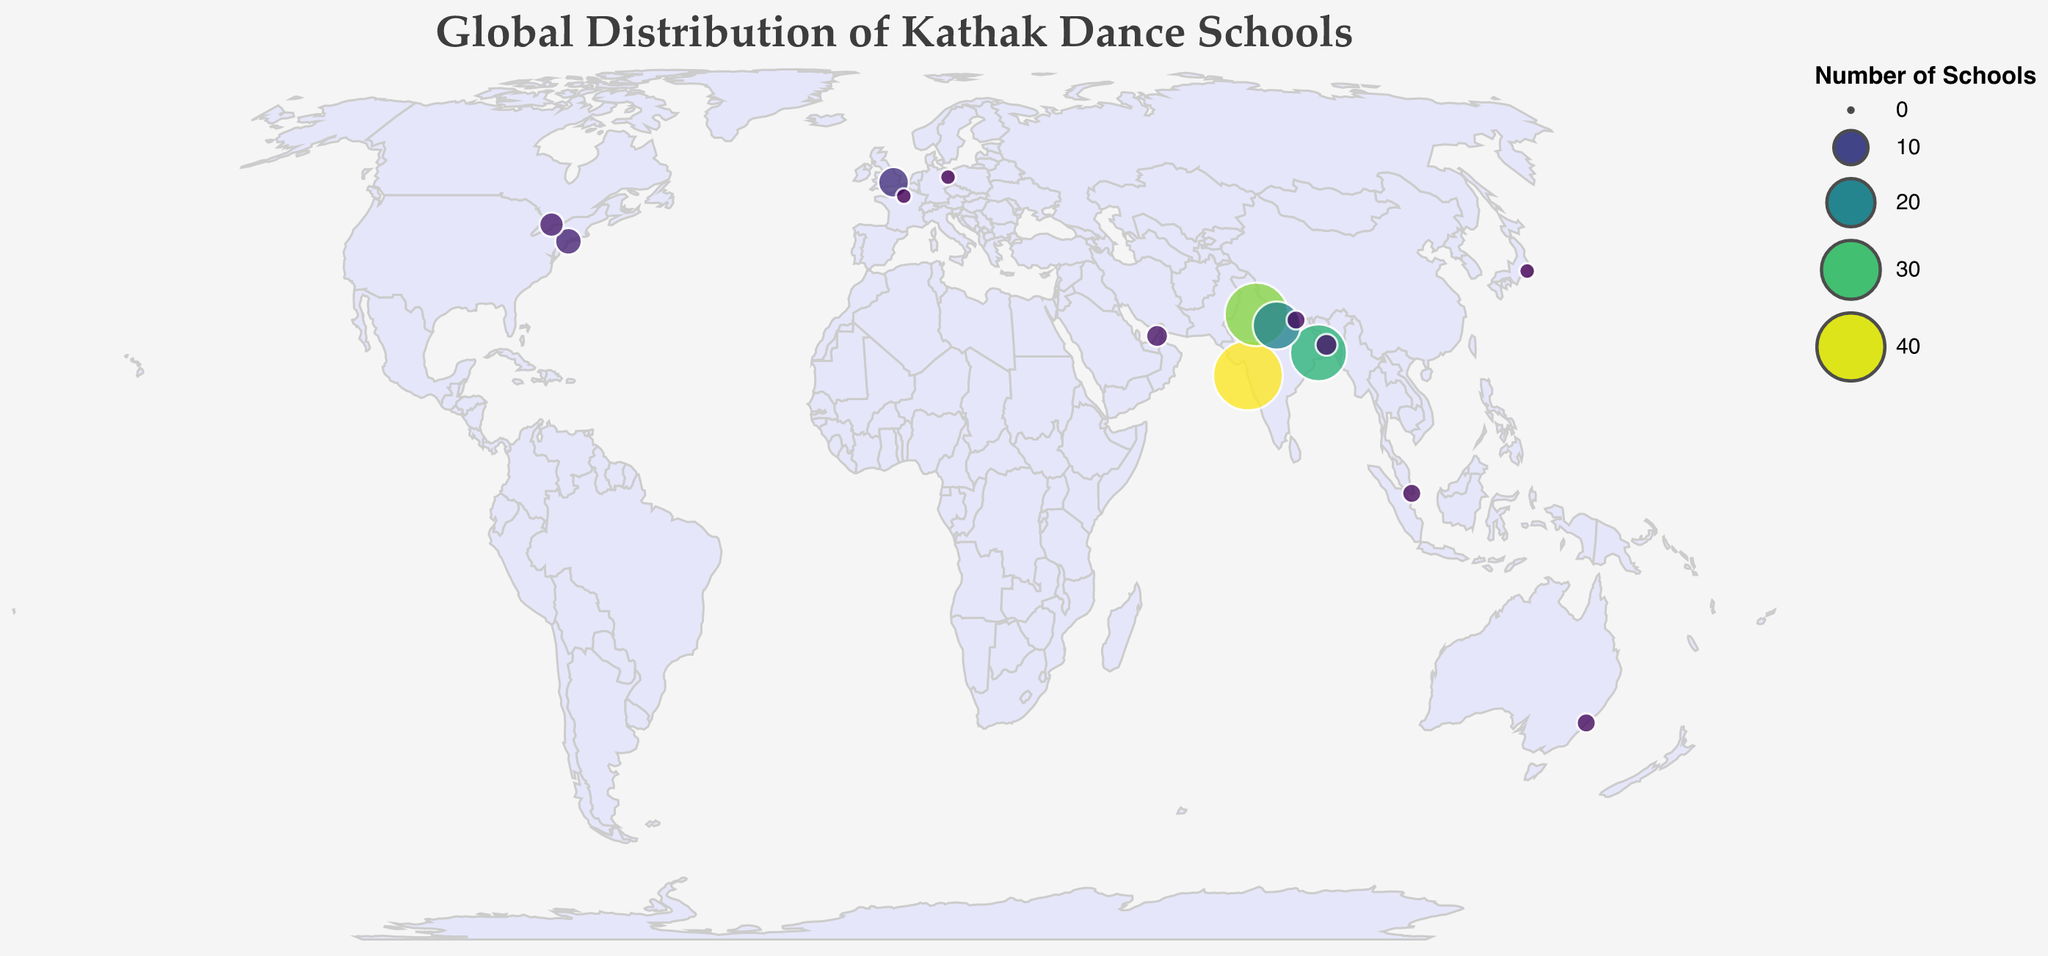What's the city with the highest number of Kathak dance schools? By looking at the size and color of the circles, Mumbai has the largest circle, indicating the highest number of schools. The tooltip confirms that Mumbai has 42 schools.
Answer: Mumbai How many Kathak dance schools are there in non-Indian cities combined? Add the number of schools in each non-Indian city: London (8) + New York City (6) + Toronto (5) + Dubai (4) + Singapore (3) + Sydney (3) + Paris (2) + Berlin (2) + Tokyo (2) = 35
Answer: 35 Which country besides India has the highest concentration of Kathak dance schools? By summing the number of schools across all cities in each non-Indian country: UK (8) has the highest number, concentrated in London.
Answer: UK What is the combined number of Kathak dance schools in Kolkata and Lucknow? Sum the number of schools in Kolkata (28) and Lucknow (20): 28 + 20 = 48
Answer: 48 Which city has more Kathak dance schools: Tokyo or Paris? Compare the number of schools: Tokyo (2) and Paris (2). Both have the same number of schools.
Answer: Both cities have the same number Is there a larger concentration of Kathak dance schools in North America or Europe? Sum the number of schools in North American cities: New York City (6) + Toronto (5) = 11. Sum the number of schools in European cities: London (8) + Paris (2) + Berlin (2) = 12. Europe has a greater number.
Answer: Europe In which continent is the least number of Kathak dance schools found? Count the schools in cities on each continent: Australia (3), Asia (Mumbai 42, Delhi 35, Kolkata 28, Lucknow 20, Dubai 4, Singapore 3, Kathmandu 3, Dhaka 4), Europe (12), North America (11). Australia has the least.
Answer: Australia What's the total number of Kathak dance schools globally? Sum the number of schools in all cities: 42 + 35 + 28 + 20 + 8 + 6 + 5 + 4 + 3 + 3 + 2 + 2 + 2 + 3 + 4 = 167
Answer: 167 